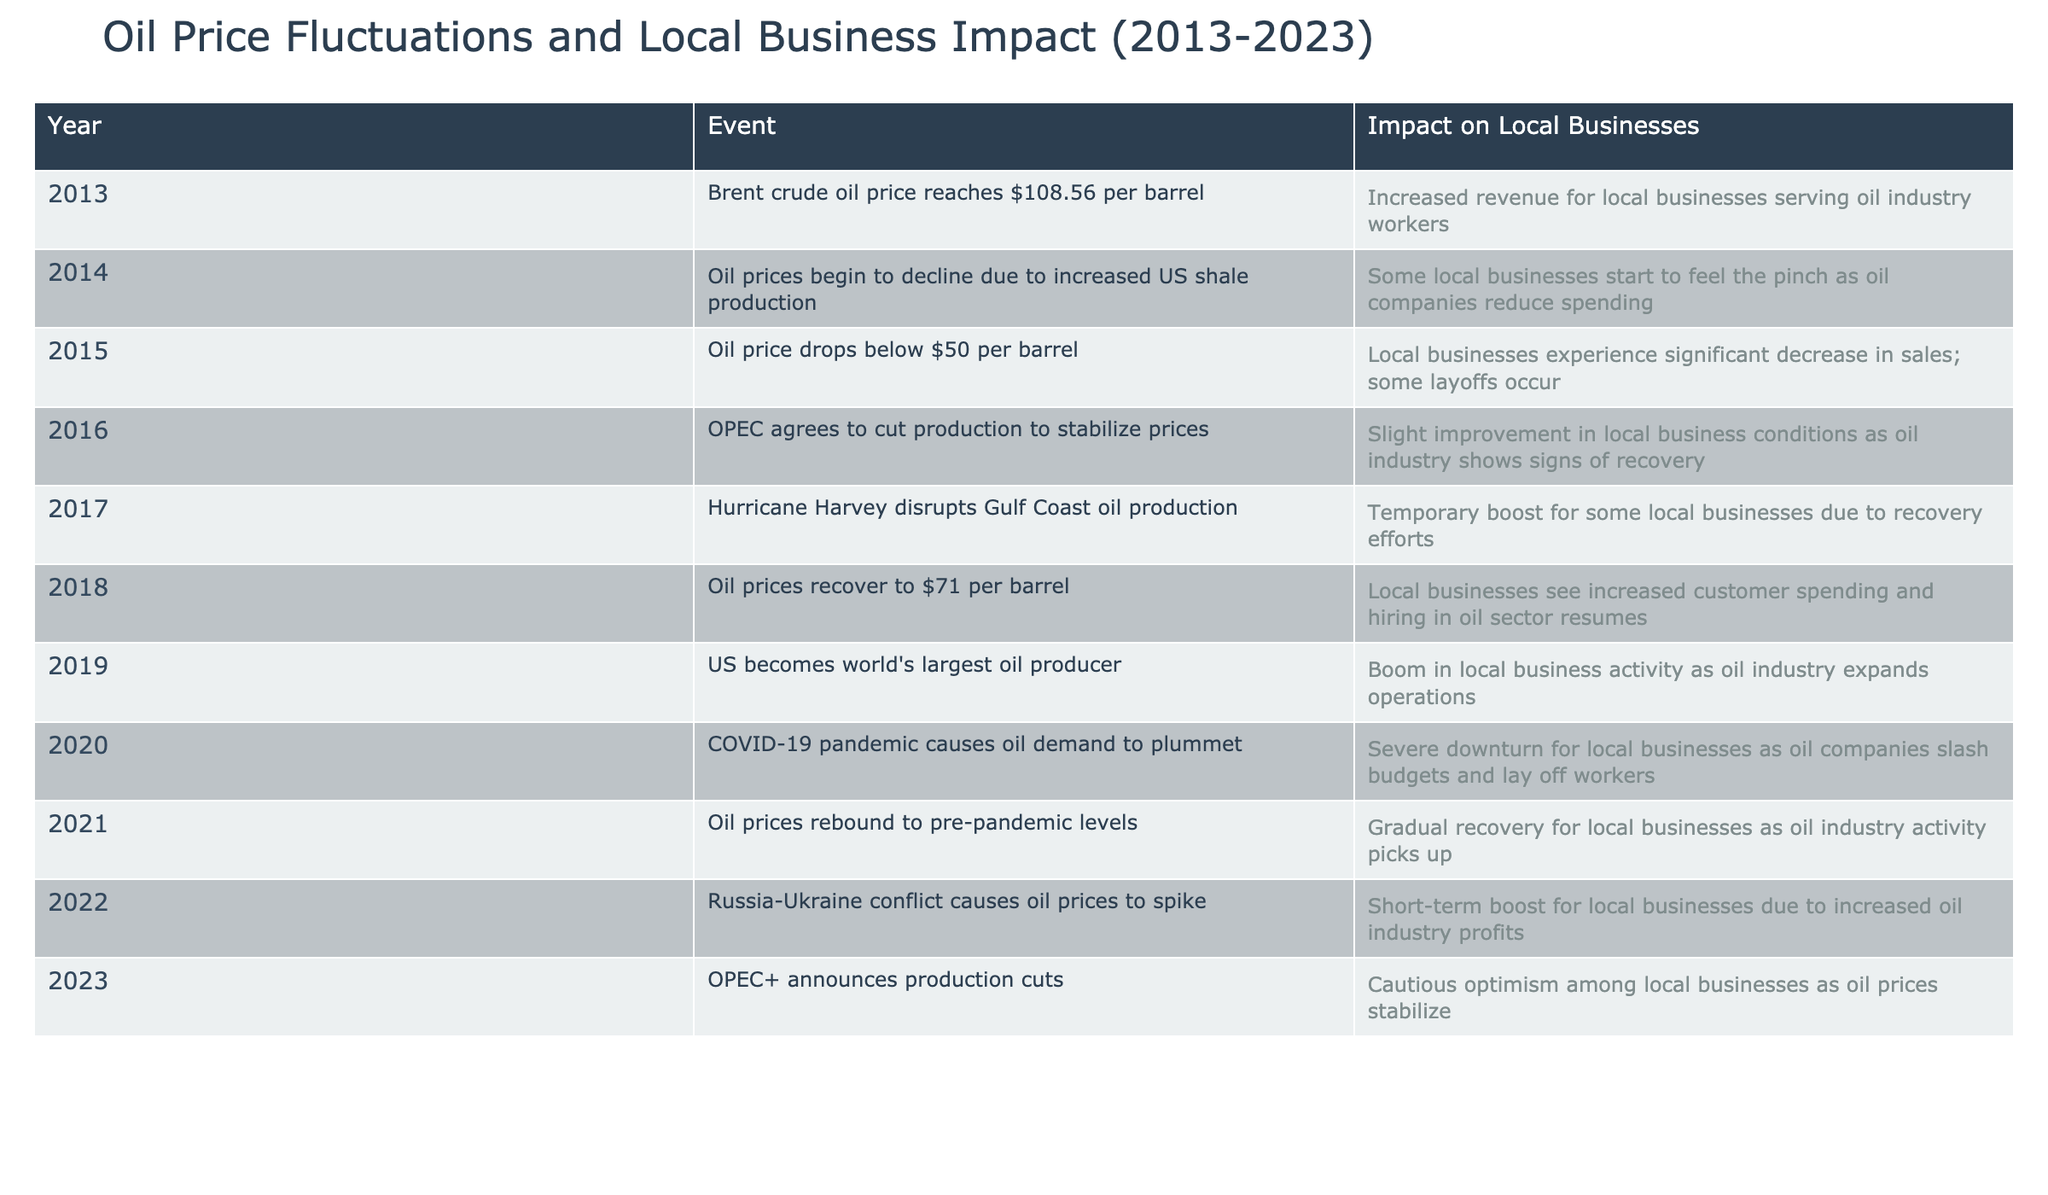What was the oil price in 2013? According to the table, the oil price in 2013 reached $108.56 per barrel.
Answer: $108.56 per barrel Which year did local businesses begin to feel the pinch due to oil companies reducing spending? In 2014, the table indicates that oil prices began to decline due to increased US shale production, leading to local businesses feeling the pinch.
Answer: 2014 What was the significant impact on local businesses in 2015? The table states that in 2015, the oil price dropped below $50 per barrel, leading to a significant decrease in sales and some layoffs for local businesses.
Answer: Significant decrease in sales; some layoffs occurred How many years had oil prices rebounded by 2021 compared to the previous downturn? Oil prices rebounded in 2021 to pre-pandemic levels. The previous downturn was in 2020 due to the COVID-19 pandemic, which means there was one year between the downturn and the recovery.
Answer: 1 year Did local businesses see increased customer spending in 2018? Yes, the table notes that in 2018, with oil prices recovering to $71 per barrel, local businesses experienced increased customer spending.
Answer: Yes What was the overall trend in local business conditions in 2016 after OPEC's decision? In 2016, after OPEC agreed to cut production to stabilize prices, there was a slight improvement in local business conditions as indicated in the table.
Answer: Slight improvement Which event in 2017 provided a temporary boost for some local businesses? The table highlights that Hurricane Harvey disrupted Gulf Coast oil production in 2017, which led to a temporary boost for local businesses due to recovery efforts.
Answer: Hurricane Harvey By how much did oil prices change from 2013 to 2023 based on the data provided? The oil price in 2013 was $108.56 per barrel, and the table does not specify the exact price in 2023, but it indicates that OPEC+ announced production cuts in 2023, leading to price stabilization. To determine the change, more specific data for 2023 would be required. Thus, the answer cannot be calculated directly from this data.
Answer: Cannot determine How many positive impacts on local businesses are listed in the table from 2013 to 2023? To calculate this, we can identify the years with a positive impact: 2013 (increased revenue), 2016 (slight improvement), 2017 (temporary boost), 2018 (increased spending), 2021 (gradual recovery), and 2022 (short-term boost). This totals to six positive impacts.
Answer: 6 positive impacts 